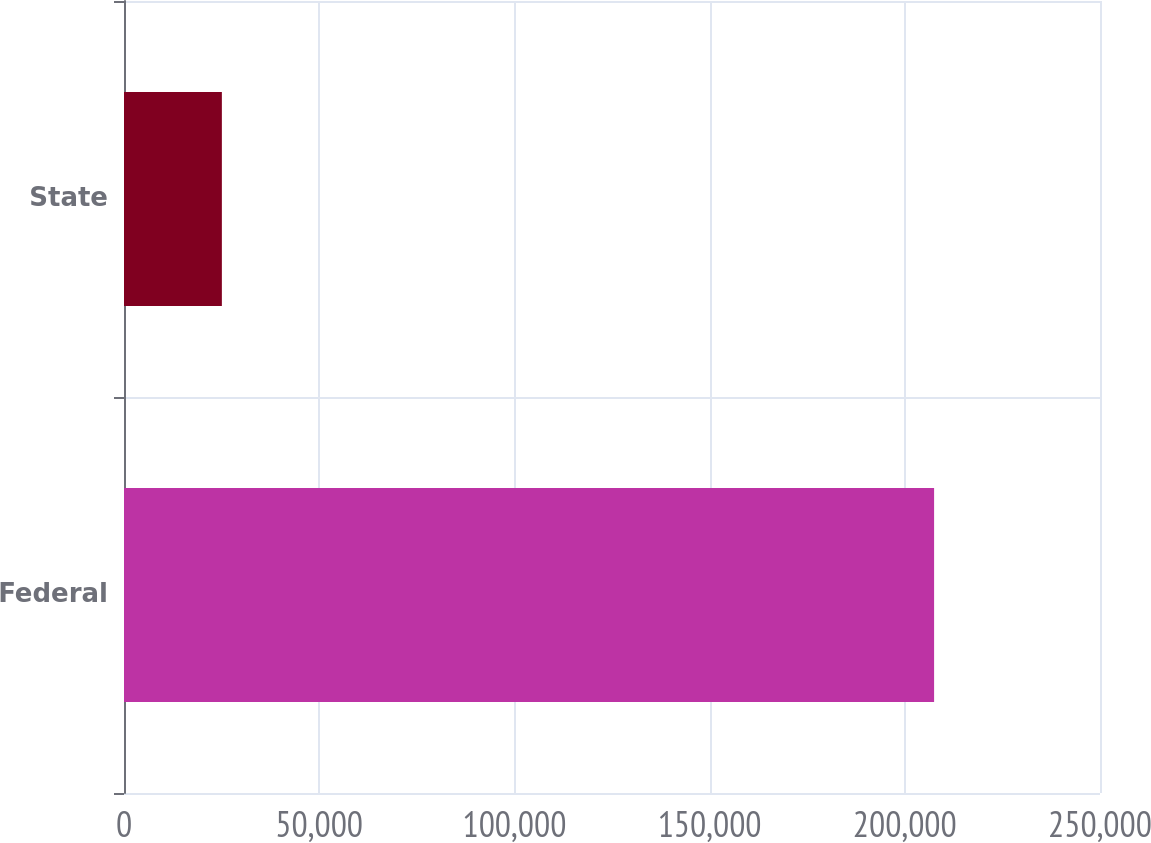Convert chart. <chart><loc_0><loc_0><loc_500><loc_500><bar_chart><fcel>Federal<fcel>State<nl><fcel>207504<fcel>25069<nl></chart> 